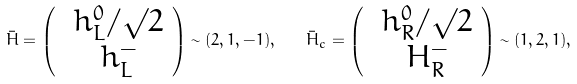Convert formula to latex. <formula><loc_0><loc_0><loc_500><loc_500>\bar { H } = \left ( \begin{array} { c c } \ h ^ { 0 } _ { L } / { \surd 2 } \\ \ h ^ { - } _ { L } \end{array} \right ) \sim ( 2 , 1 , - 1 ) , \quad \bar { H } _ { c } = \left ( \begin{array} { c c } \ h ^ { 0 } _ { R } / { \surd 2 } \\ \ H ^ { - } _ { R } \end{array} \right ) \sim ( 1 , 2 , 1 ) ,</formula> 